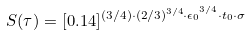Convert formula to latex. <formula><loc_0><loc_0><loc_500><loc_500>S ( \tau ) = [ 0 . 1 4 ] ^ { ( 3 / 4 ) \cdot { ( 2 / 3 ) ^ { 3 / 4 } \cdot { \epsilon } _ { 0 } } ^ { 3 / 4 } \cdot t _ { 0 } \cdot \sigma }</formula> 